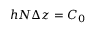<formula> <loc_0><loc_0><loc_500><loc_500>h N \Delta z = C _ { 0 }</formula> 